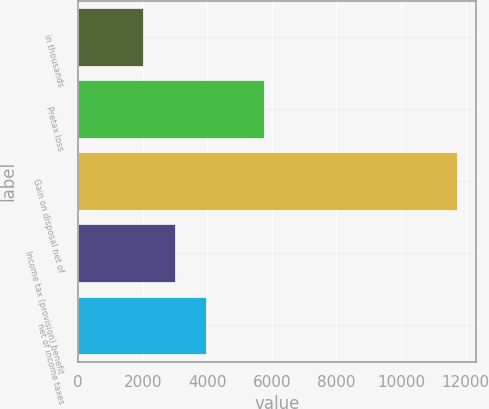Convert chart to OTSL. <chart><loc_0><loc_0><loc_500><loc_500><bar_chart><fcel>in thousands<fcel>Pretax loss<fcel>Gain on disposal net of<fcel>Income tax (provision) benefit<fcel>net of income taxes<nl><fcel>2013<fcel>5744<fcel>11728<fcel>2984.5<fcel>3956<nl></chart> 